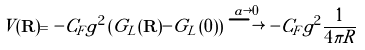<formula> <loc_0><loc_0><loc_500><loc_500>V ( { \mathbf R } ) = - C _ { F } g ^ { 2 } \left ( G _ { L } ( { \mathbf R } ) - G _ { L } ( { \mathbf 0 } ) \right ) \stackrel { a \rightarrow 0 } { \longrightarrow } - C _ { F } g ^ { 2 } \frac { 1 } { 4 \pi R }</formula> 